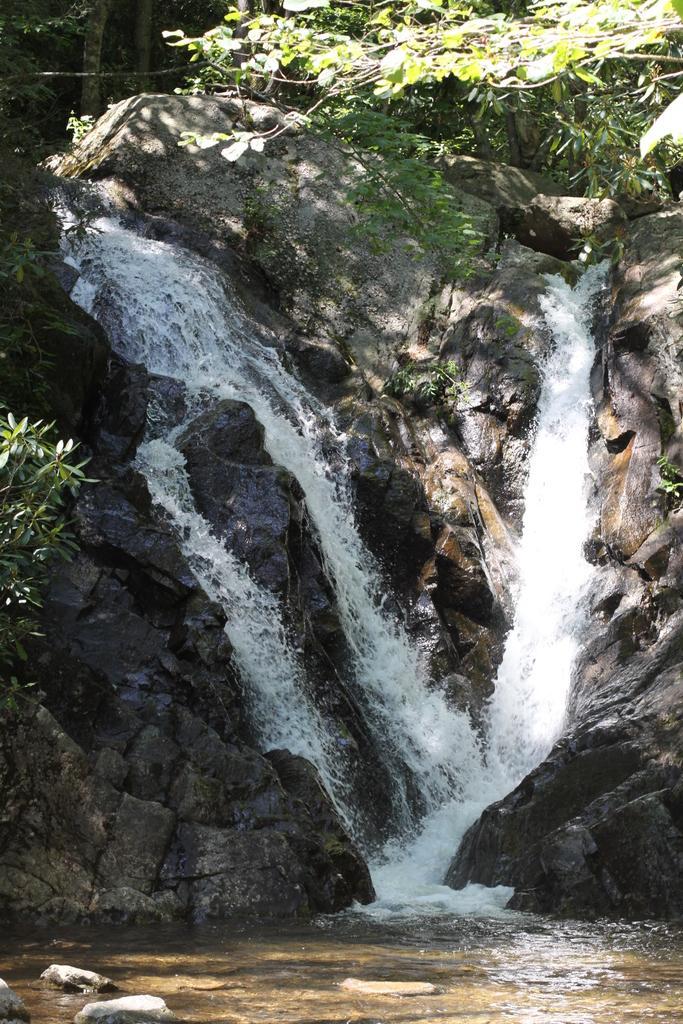How would you summarize this image in a sentence or two? In this image, we can see the waterfall. We can see some trees, and rocks. 